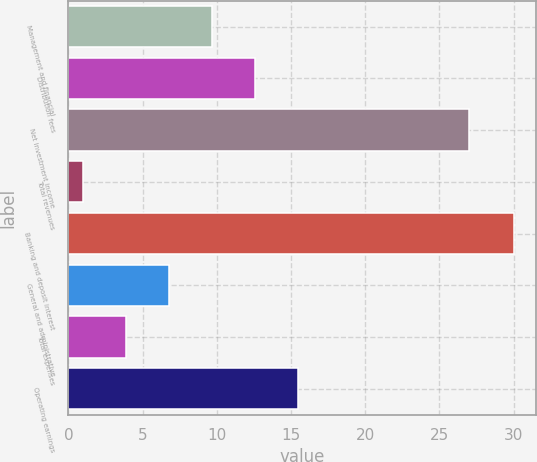Convert chart to OTSL. <chart><loc_0><loc_0><loc_500><loc_500><bar_chart><fcel>Management and financial<fcel>Distribution fees<fcel>Net investment income<fcel>Total revenues<fcel>Banking and deposit interest<fcel>General and administrative<fcel>Total expenses<fcel>Operating earnings<nl><fcel>9.7<fcel>12.6<fcel>27<fcel>1<fcel>30<fcel>6.8<fcel>3.9<fcel>15.5<nl></chart> 